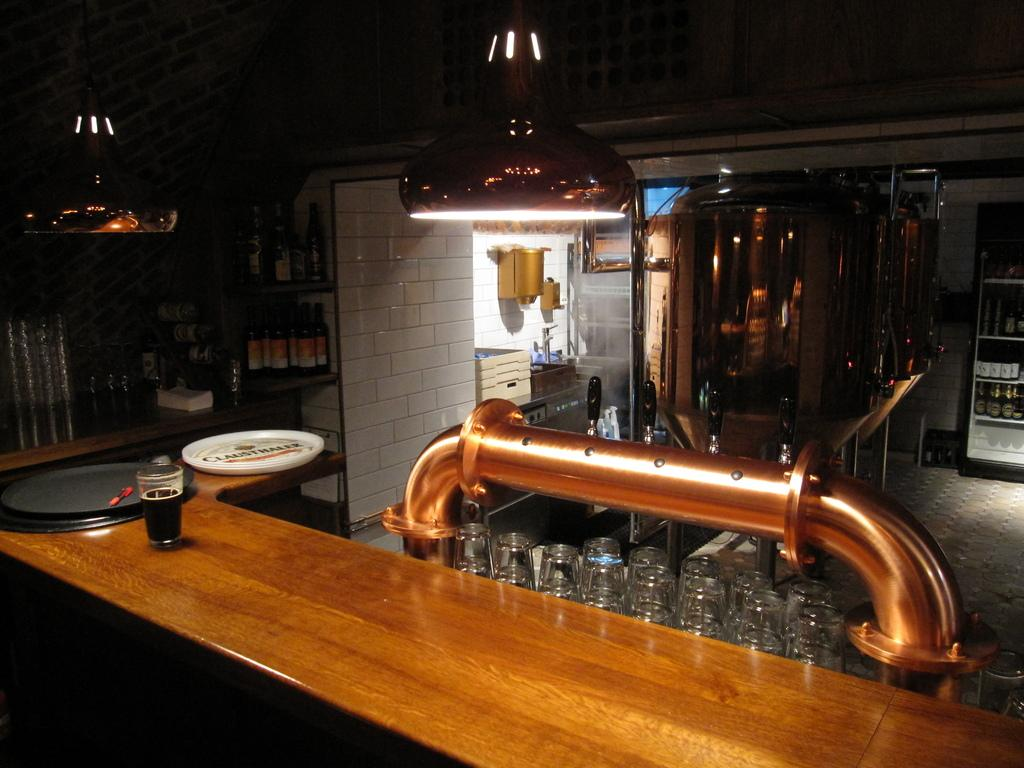What type of furniture or fixture is present in the image? There is a mini bar in the image. What items can be found inside the mini bar? The mini bar contains glasses and bottles. What appliance is present in the mini bar? There is a fridge in the mini bar. How is the mini bar illuminated? The mini bar has a light. What is on the table in the image? There is a glass with liquid on the table. Can you see the home or father of the person who owns the mini bar in the image? The image does not show the home or father of the person who owns the mini bar; it only shows the mini bar and its contents. 